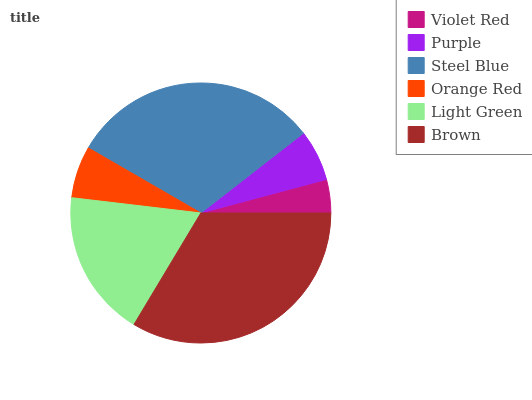Is Violet Red the minimum?
Answer yes or no. Yes. Is Brown the maximum?
Answer yes or no. Yes. Is Purple the minimum?
Answer yes or no. No. Is Purple the maximum?
Answer yes or no. No. Is Purple greater than Violet Red?
Answer yes or no. Yes. Is Violet Red less than Purple?
Answer yes or no. Yes. Is Violet Red greater than Purple?
Answer yes or no. No. Is Purple less than Violet Red?
Answer yes or no. No. Is Light Green the high median?
Answer yes or no. Yes. Is Orange Red the low median?
Answer yes or no. Yes. Is Purple the high median?
Answer yes or no. No. Is Purple the low median?
Answer yes or no. No. 